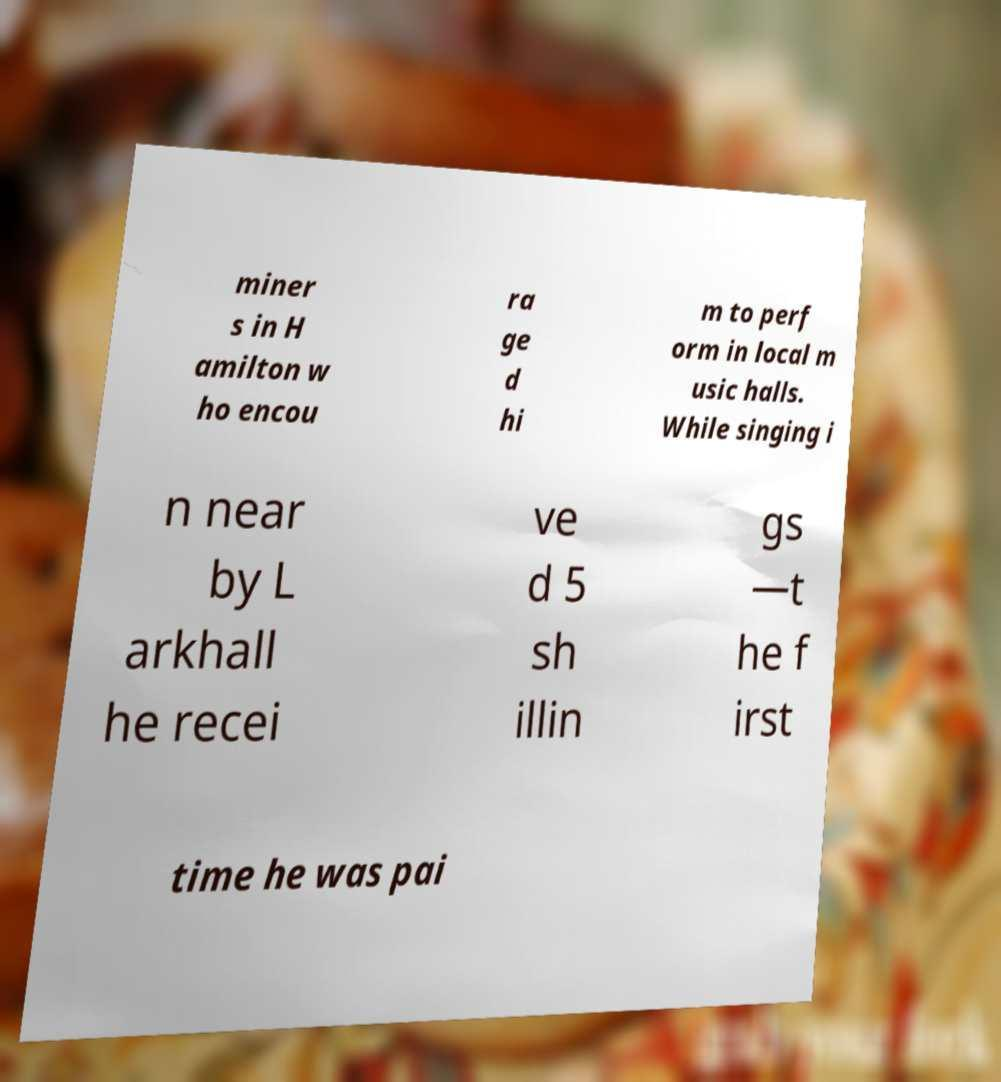I need the written content from this picture converted into text. Can you do that? miner s in H amilton w ho encou ra ge d hi m to perf orm in local m usic halls. While singing i n near by L arkhall he recei ve d 5 sh illin gs —t he f irst time he was pai 